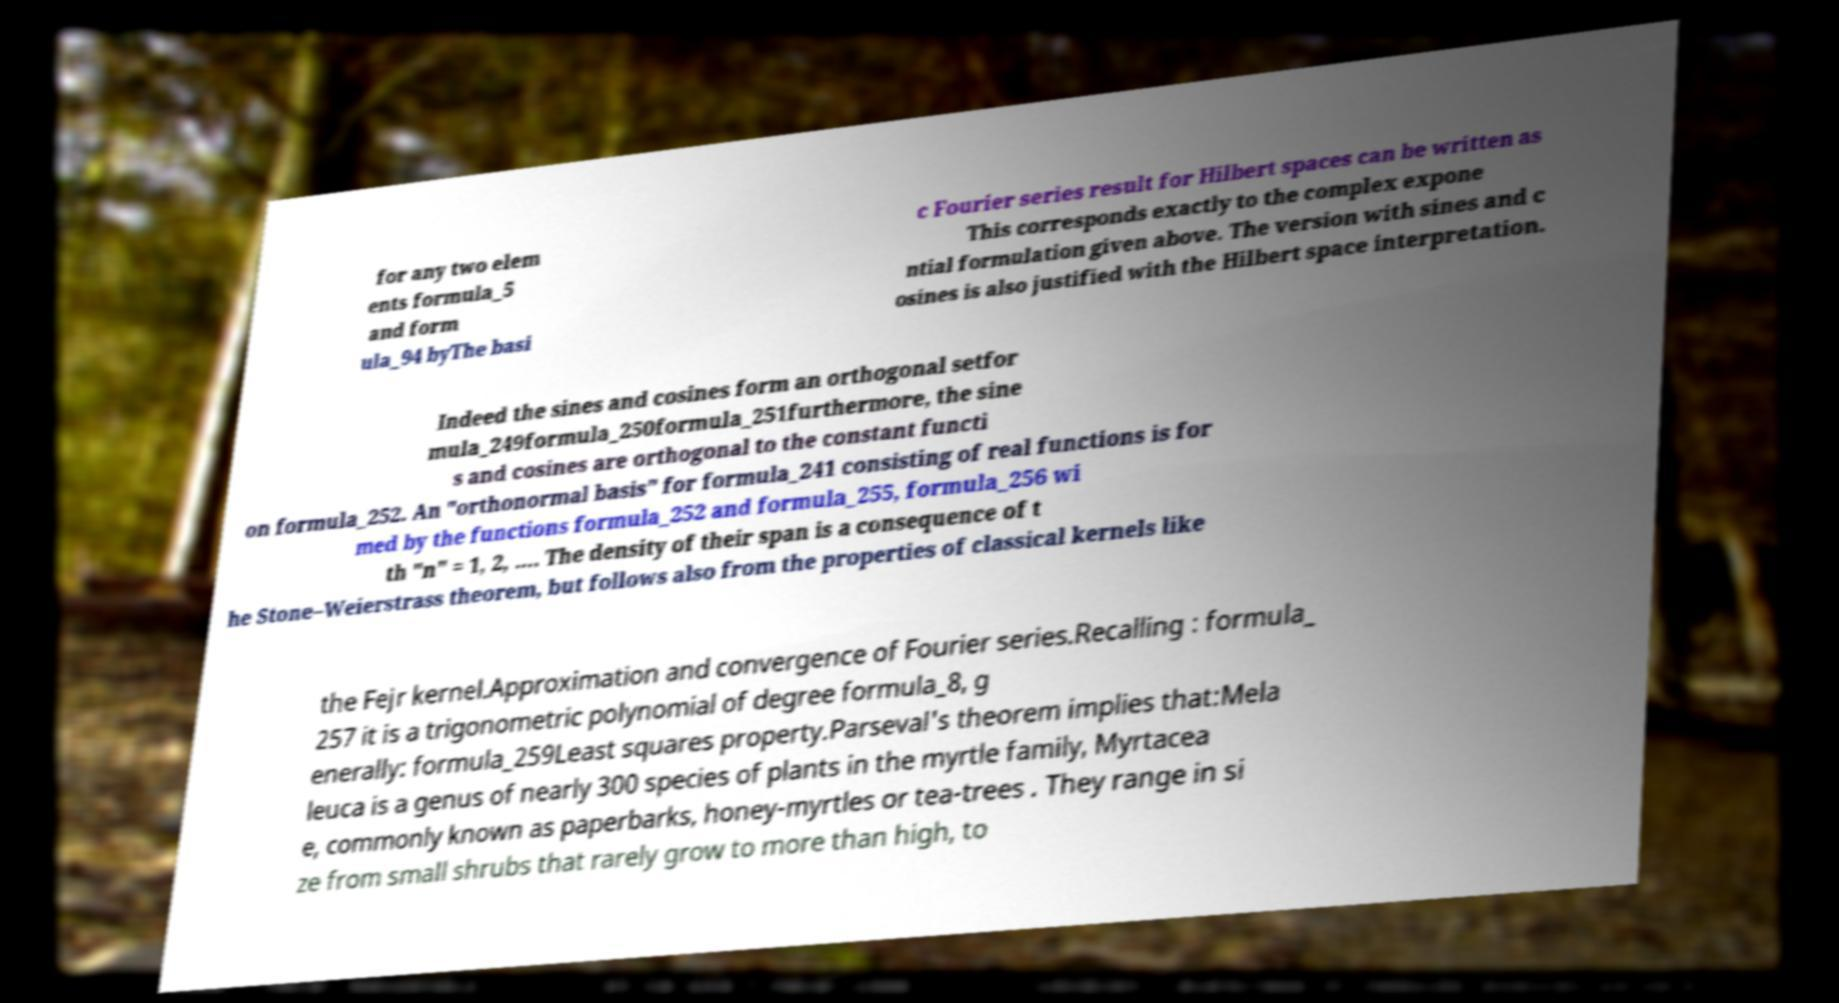What messages or text are displayed in this image? I need them in a readable, typed format. for any two elem ents formula_5 and form ula_94 byThe basi c Fourier series result for Hilbert spaces can be written as This corresponds exactly to the complex expone ntial formulation given above. The version with sines and c osines is also justified with the Hilbert space interpretation. Indeed the sines and cosines form an orthogonal setfor mula_249formula_250formula_251furthermore, the sine s and cosines are orthogonal to the constant functi on formula_252. An "orthonormal basis" for formula_241 consisting of real functions is for med by the functions formula_252 and formula_255, formula_256 wi th "n" = 1, 2, …. The density of their span is a consequence of t he Stone–Weierstrass theorem, but follows also from the properties of classical kernels like the Fejr kernel.Approximation and convergence of Fourier series.Recalling : formula_ 257 it is a trigonometric polynomial of degree formula_8, g enerally: formula_259Least squares property.Parseval's theorem implies that:Mela leuca is a genus of nearly 300 species of plants in the myrtle family, Myrtacea e, commonly known as paperbarks, honey-myrtles or tea-trees . They range in si ze from small shrubs that rarely grow to more than high, to 